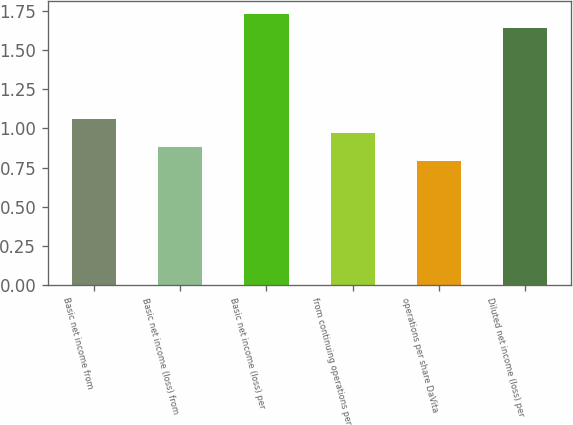Convert chart to OTSL. <chart><loc_0><loc_0><loc_500><loc_500><bar_chart><fcel>Basic net income from<fcel>Basic net income (loss) from<fcel>Basic net income (loss) per<fcel>from continuing operations per<fcel>operations per share DaVita<fcel>Diluted net income (loss) per<nl><fcel>1.06<fcel>0.88<fcel>1.73<fcel>0.97<fcel>0.79<fcel>1.64<nl></chart> 